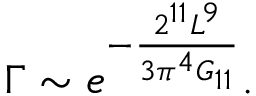<formula> <loc_0><loc_0><loc_500><loc_500>\Gamma \sim e ^ { - \frac { 2 ^ { 1 1 } L ^ { 9 } } { 3 \pi ^ { 4 } G _ { 1 1 } } } .</formula> 